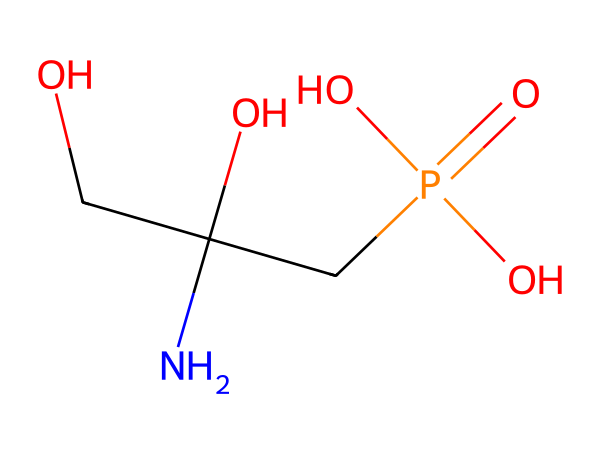What is the molecular formula of glyphosate? To determine the molecular formula, we analyze the SMILES representation and count the atoms of each element. There are 3 carbons (C), 8 hydrogens (H), 1 nitrogen (N), and 5 oxygens (O). Therefore, the molecular formula is C3H8N O5.
Answer: C3H8N O5 How many carbon atoms are present in glyphosate? From the SMILES representation, we identify the number of carbon atoms directly, which is 3.
Answer: 3 What functional groups are present in glyphosate? By examining the structure, we can identify the phosphate group (P(=O)(O)O) and an amine group (–NH). These are key functional groups in glyphosate.
Answer: phosphate and amine How many oxygen atoms are involved in the phosphate group of glyphosate? In the phosphate group represented as P(=O)(O)O, there are 4 oxygen atoms in total, considering one double-bonded oxygen and three single-bonded ones.
Answer: 4 What is the significance of the nitrogen atom in glyphosate's structure? The nitrogen atom is part of the amine functional group, which contributes to the herbicidal properties of glyphosate and is involved in biological interactions.
Answer: herbicidal properties Does glyphosate contain any ring structures? By examining the SMILES, we see that glyphosate has a linear structure without any closed cyclic components.
Answer: no 